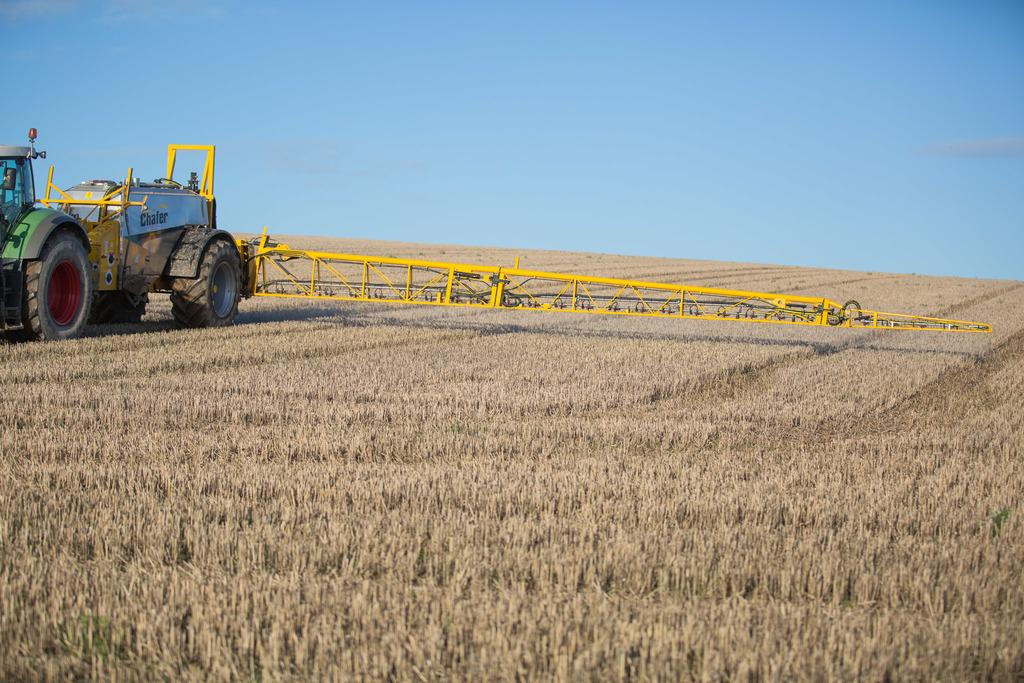What is the main subject of the image? The main subject of the image is a tractor. Where is the tractor located in the image? The tractor is on the left side of the image. What type of vegetation can be seen in the image? There is dry grass in the image. What color is the sky in the background? The sky in the background is plain blue. What other object can be seen in the image besides the tractor? There is a yellow object in the image. What time of day is it at the seashore in the image? There is no seashore present in the image; it features a tractor and dry grass. What type of crack is visible on the tractor's wheel in the image? There is no crack visible on the tractor's wheel in the image. 